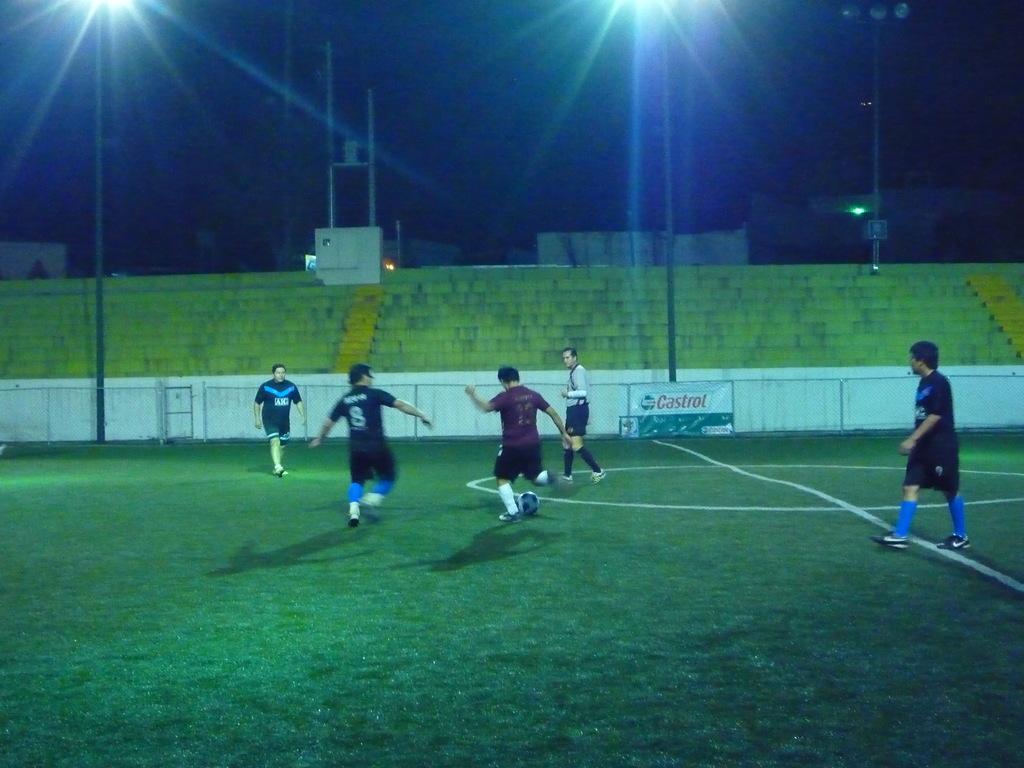What number player is trying to make a tackle on the ball?
Give a very brief answer. 8. 